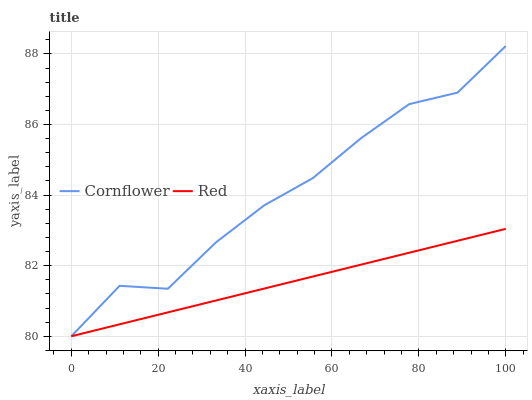Does Red have the minimum area under the curve?
Answer yes or no. Yes. Does Cornflower have the maximum area under the curve?
Answer yes or no. Yes. Does Red have the maximum area under the curve?
Answer yes or no. No. Is Red the smoothest?
Answer yes or no. Yes. Is Cornflower the roughest?
Answer yes or no. Yes. Is Red the roughest?
Answer yes or no. No. Does Cornflower have the lowest value?
Answer yes or no. Yes. Does Cornflower have the highest value?
Answer yes or no. Yes. Does Red have the highest value?
Answer yes or no. No. Does Cornflower intersect Red?
Answer yes or no. Yes. Is Cornflower less than Red?
Answer yes or no. No. Is Cornflower greater than Red?
Answer yes or no. No. 